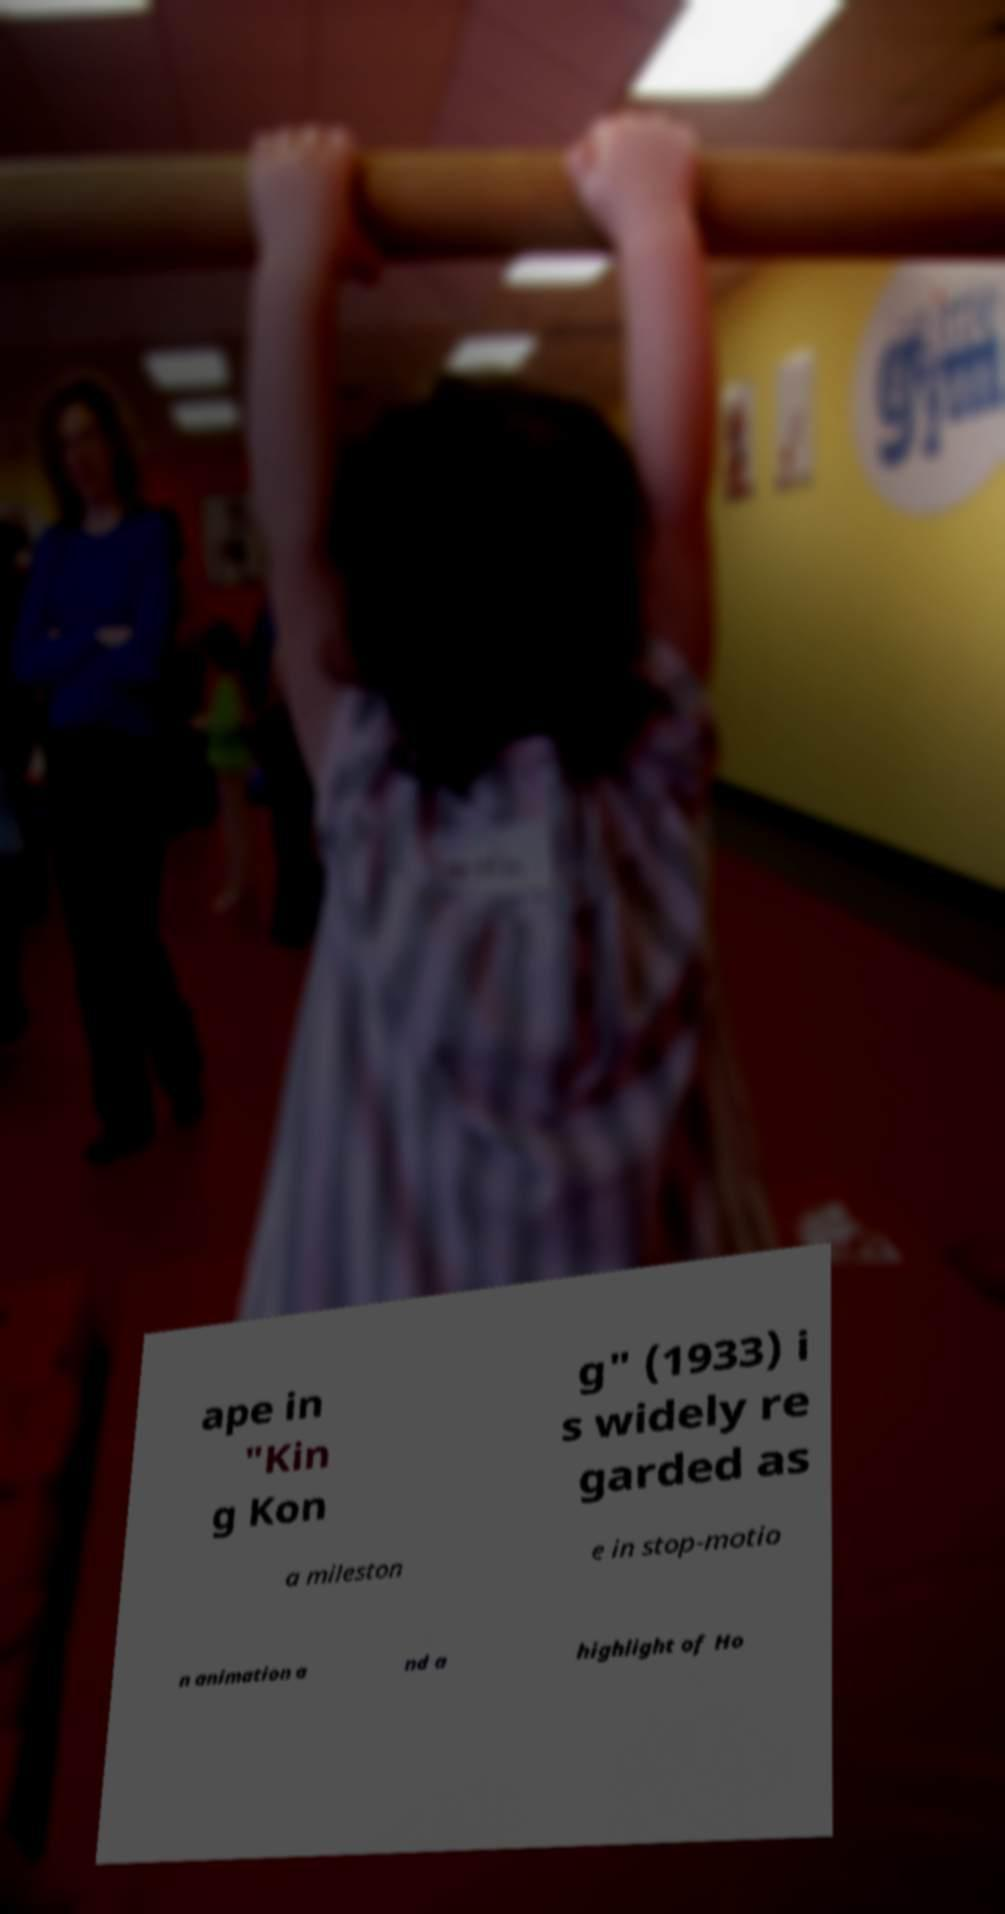What messages or text are displayed in this image? I need them in a readable, typed format. ape in "Kin g Kon g" (1933) i s widely re garded as a mileston e in stop-motio n animation a nd a highlight of Ho 